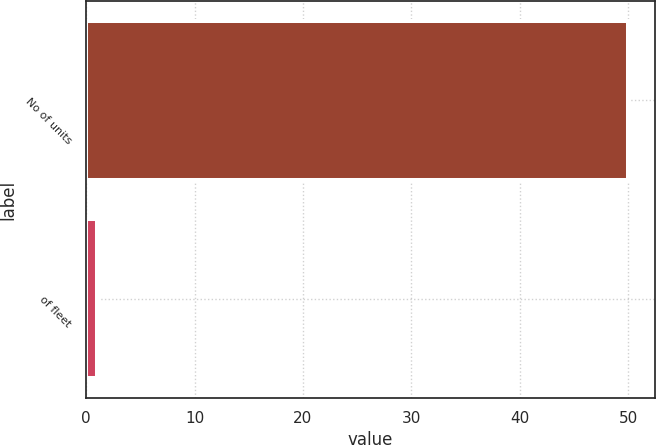Convert chart to OTSL. <chart><loc_0><loc_0><loc_500><loc_500><bar_chart><fcel>No of units<fcel>of fleet<nl><fcel>50<fcel>1<nl></chart> 